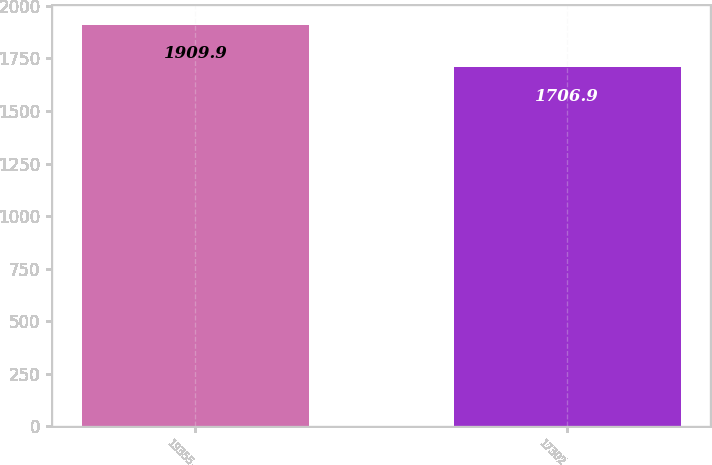<chart> <loc_0><loc_0><loc_500><loc_500><bar_chart><fcel>19355<fcel>17302<nl><fcel>1909.9<fcel>1706.9<nl></chart> 